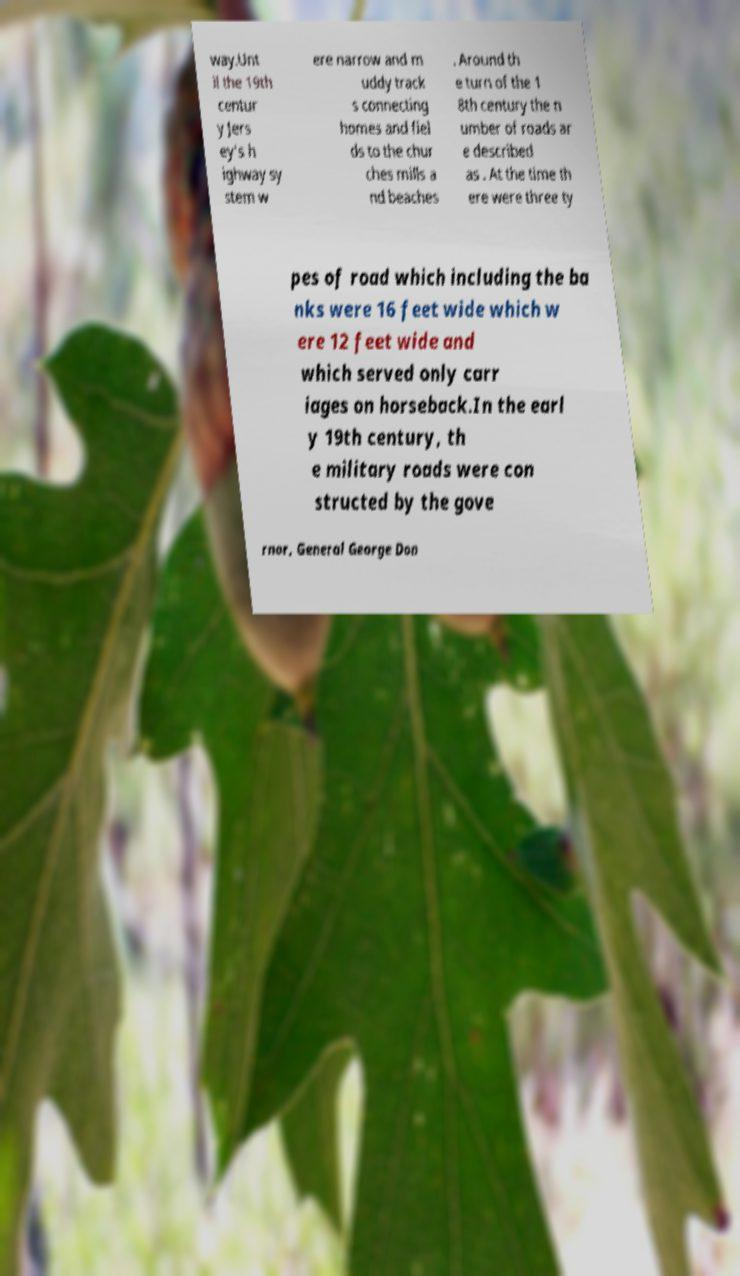Can you accurately transcribe the text from the provided image for me? way.Unt il the 19th centur y Jers ey's h ighway sy stem w ere narrow and m uddy track s connecting homes and fiel ds to the chur ches mills a nd beaches . Around th e turn of the 1 8th century the n umber of roads ar e described as . At the time th ere were three ty pes of road which including the ba nks were 16 feet wide which w ere 12 feet wide and which served only carr iages on horseback.In the earl y 19th century, th e military roads were con structed by the gove rnor, General George Don 